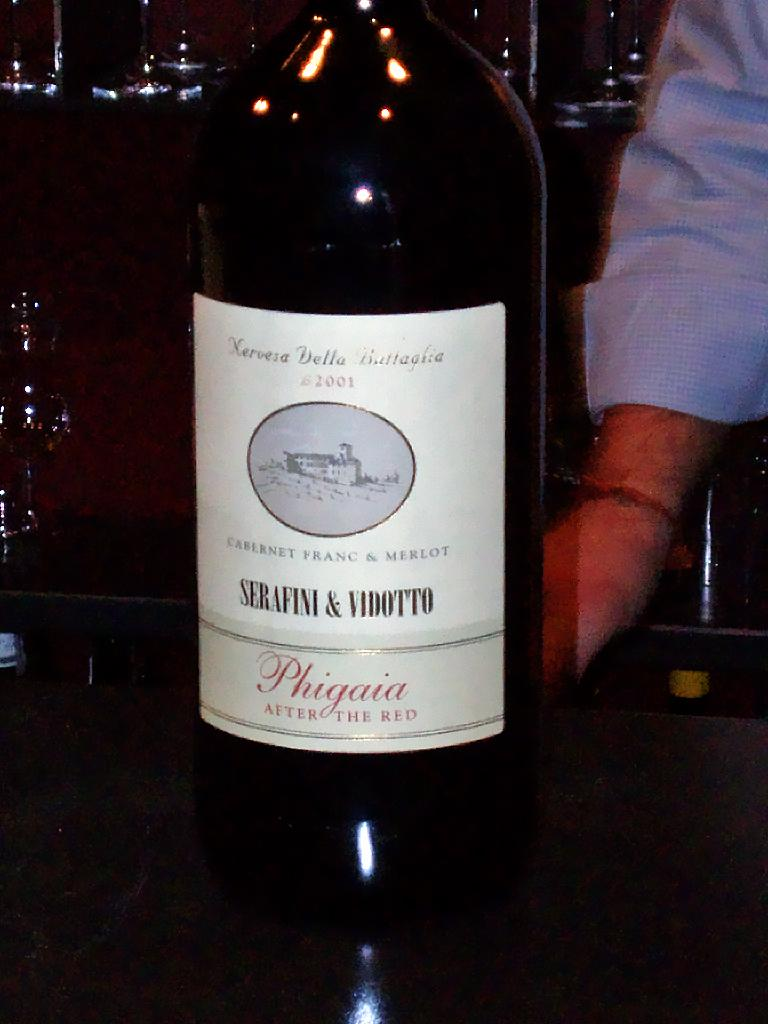What is the color of the wine bottle in the image? The wine bottle in the image is black. Where is the wine bottle placed in the image? The wine bottle is placed on a table. What is the man in the image wearing? The man in the image is wearing a blue color shirt. How much of the man's image is visible in the image? The man's image is only half visible in the image. What type of horse can be seen in the image? There is no horse present in the image. What time of day is depicted in the image? The time of day is not mentioned or depicted in the image. 